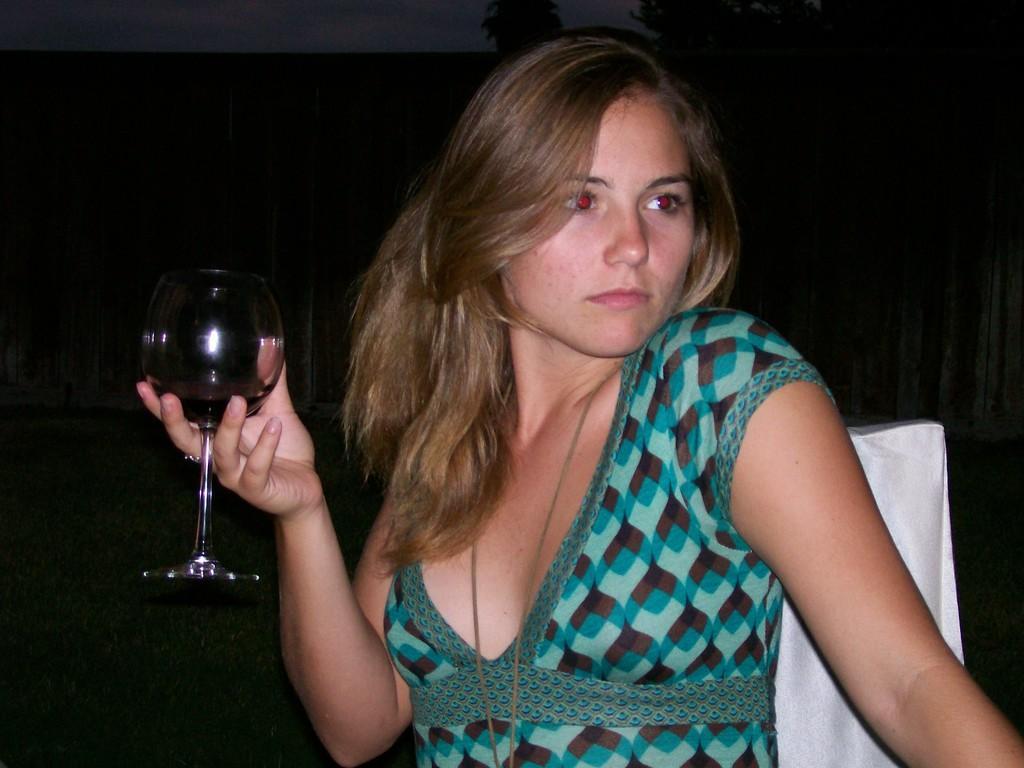Describe this image in one or two sentences. In the picture there is a woman in green dress holding a glass. Background is dark. There is a chair on the right. 